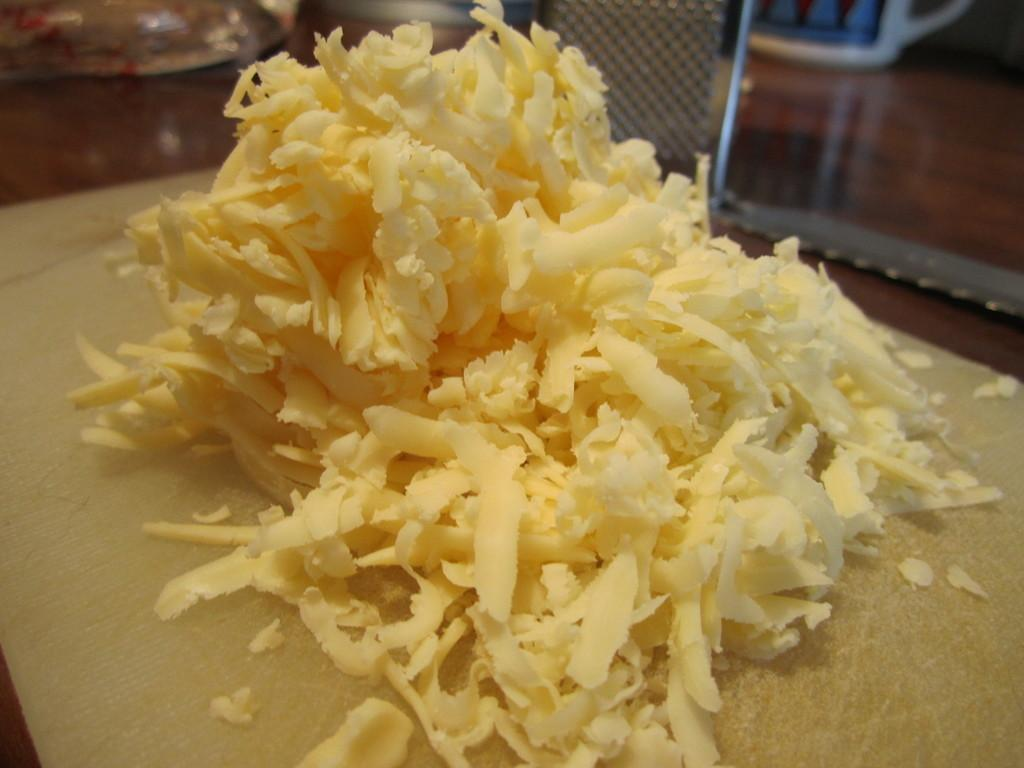What is the main color of the object in the image? The main color of the object in the image is cream. What type of container is visible in the image? There is a mug in the image. How would you describe the overall clarity of the image? The image is slightly blurry in the background. What type of crayon is being used to draw on the knee in the image? There is no crayon or drawing on a knee present in the image. 